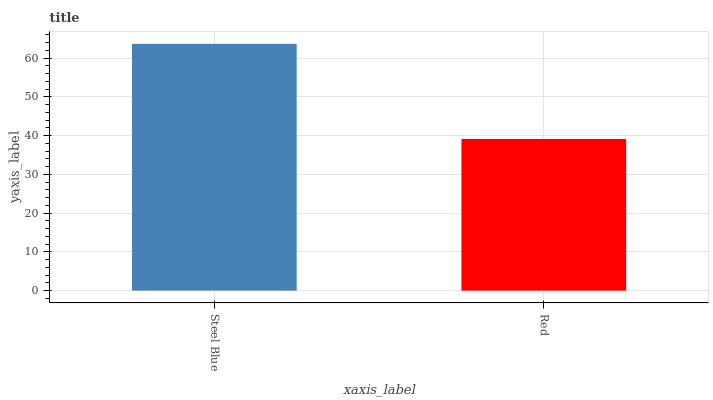Is Red the minimum?
Answer yes or no. Yes. Is Steel Blue the maximum?
Answer yes or no. Yes. Is Red the maximum?
Answer yes or no. No. Is Steel Blue greater than Red?
Answer yes or no. Yes. Is Red less than Steel Blue?
Answer yes or no. Yes. Is Red greater than Steel Blue?
Answer yes or no. No. Is Steel Blue less than Red?
Answer yes or no. No. Is Steel Blue the high median?
Answer yes or no. Yes. Is Red the low median?
Answer yes or no. Yes. Is Red the high median?
Answer yes or no. No. Is Steel Blue the low median?
Answer yes or no. No. 